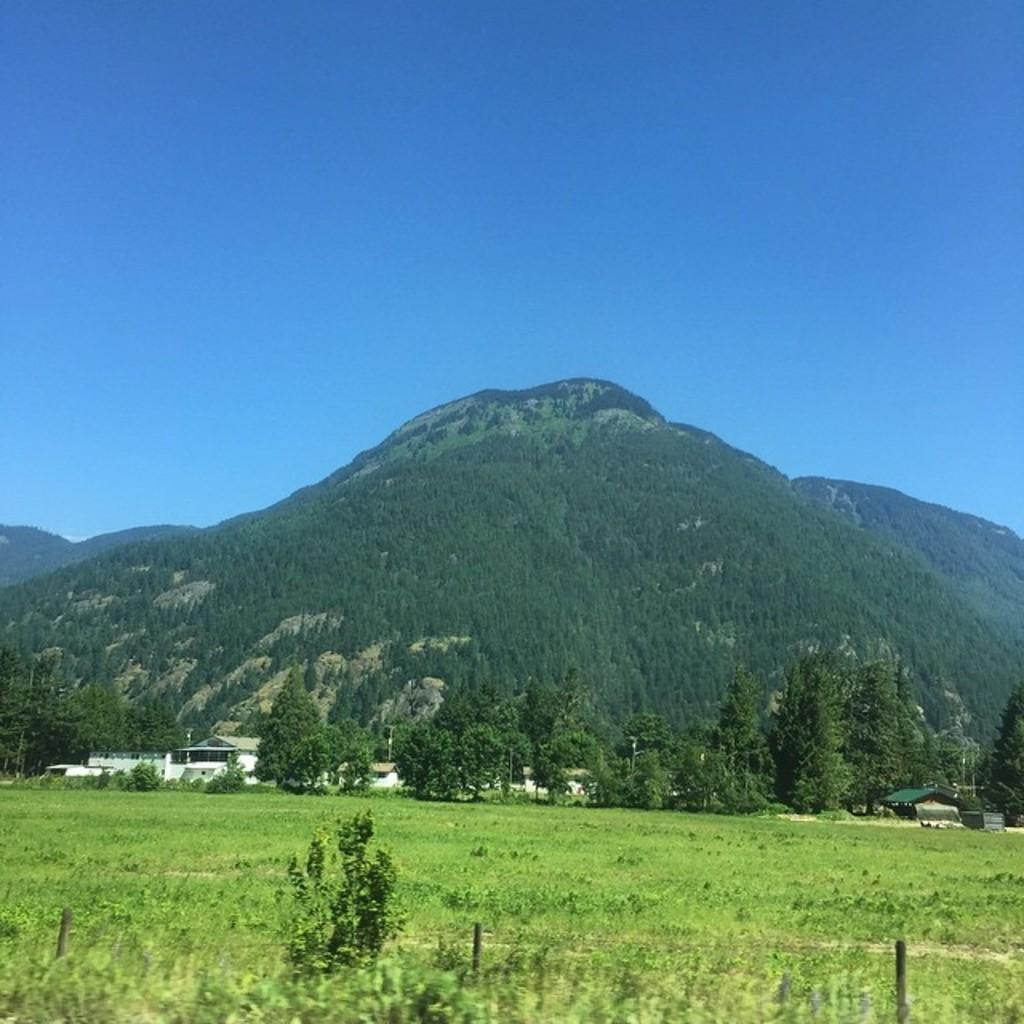What type of vegetation is present in the image? There is grass and trees in the image. What can be seen in the background of the image? Hills and the sky are visible in the background of the image. What type of pencil can be seen in the image? There is no pencil present in the image. What color is the elbow of the person in the image? There is no person or elbow visible in the image. 